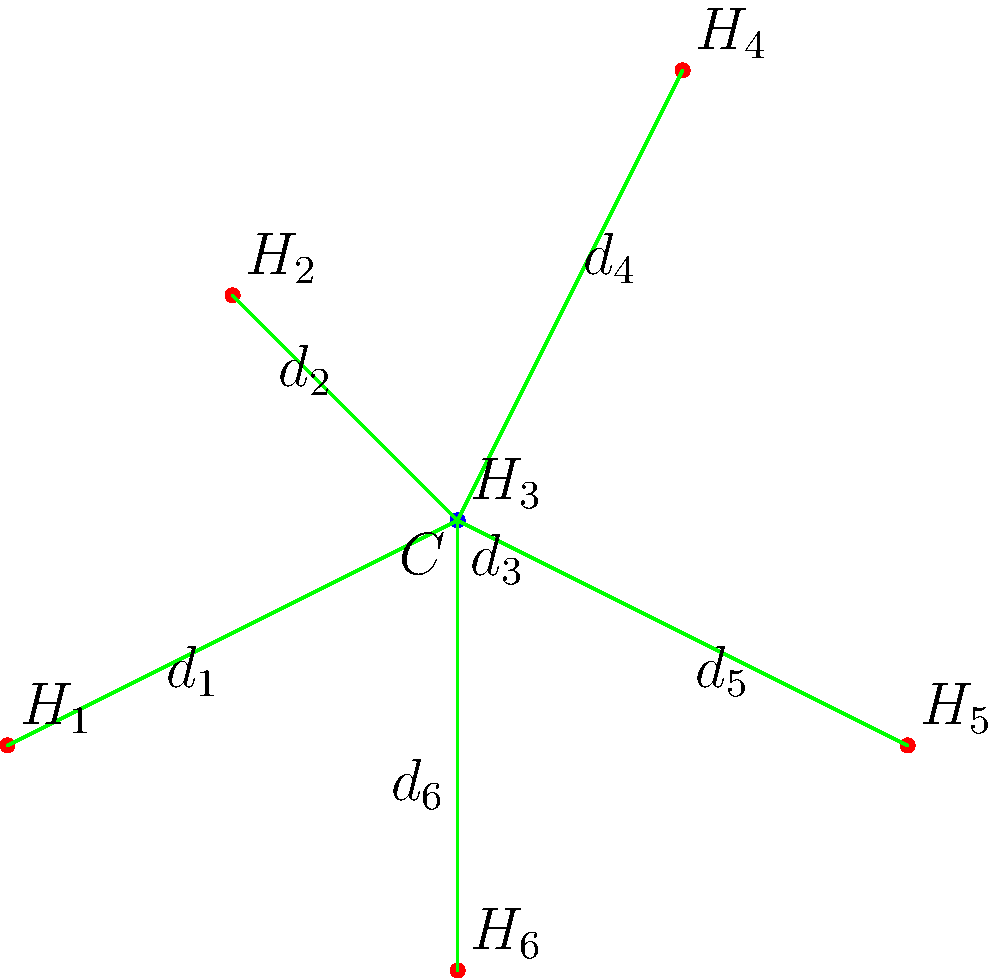In our village of Banseli, we want to connect all homes to a central community center using the most efficient network structure. The diagram shows six homes ($H_1$ to $H_6$) and a central community center ($C$). What network structure would minimize the total length of connections while ensuring all homes are connected to the center? To find the most efficient network structure for connecting village homes to a central community center, we need to consider the following steps:

1. Observe the given diagram: We have six homes ($H_1$ to $H_6$) and a central community center ($C$).

2. Understand the goal: We want to minimize the total length of connections while ensuring all homes are connected to the center.

3. Consider possible network structures:
   a) Star topology: Each home is directly connected to the center.
   b) Tree topology: Some homes are connected to others, forming a branching structure.
   c) Mesh topology: Homes are interconnected with multiple paths.

4. Analyze the options:
   a) Star topology:
      - Ensures direct connection for each home to the center.
      - Minimizes the number of connections (6 in total).
      - Each home has the shortest possible path to the center.

   b) Tree topology:
      - May reduce total cable length in some cases.
      - Increases complexity and potential points of failure.
      - Some homes would have indirect access to the center.

   c) Mesh topology:
      - Provides redundancy but greatly increases total cable length.
      - Unnecessarily complex for this scenario.

5. Consider the village context:
   - Direct access to the community center is important for all villagers.
   - Simplicity in maintenance and troubleshooting is valuable.

6. Conclusion:
   The star topology (option a) is the most efficient network structure for this scenario. It provides:
   - Direct connections for all homes to the center.
   - Minimal total cable length (sum of distances $d_1$ to $d_6$).
   - Simplicity in design and maintenance.
   - Equal access for all villagers to the community center.
Answer: Star topology 